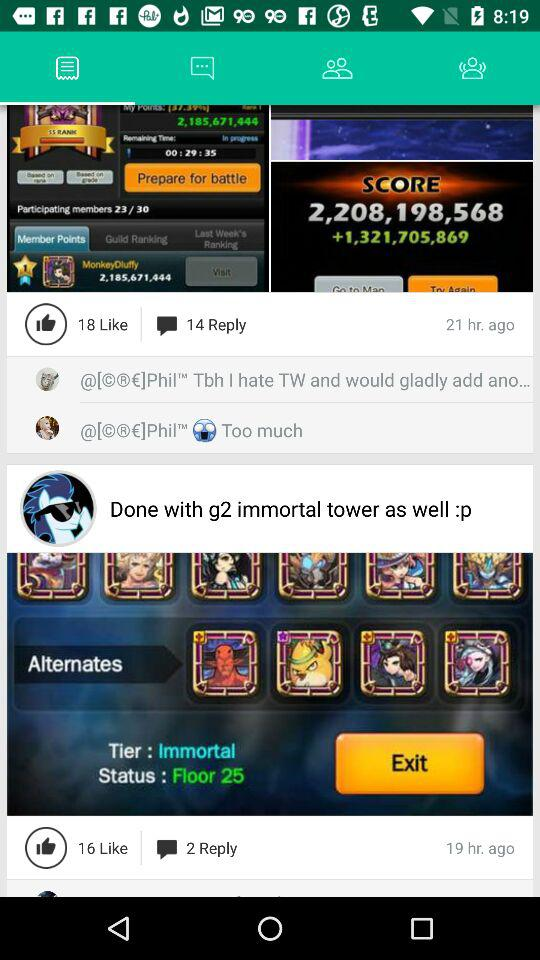What is the score?
When the provided information is insufficient, respond with <no answer>. <no answer> 